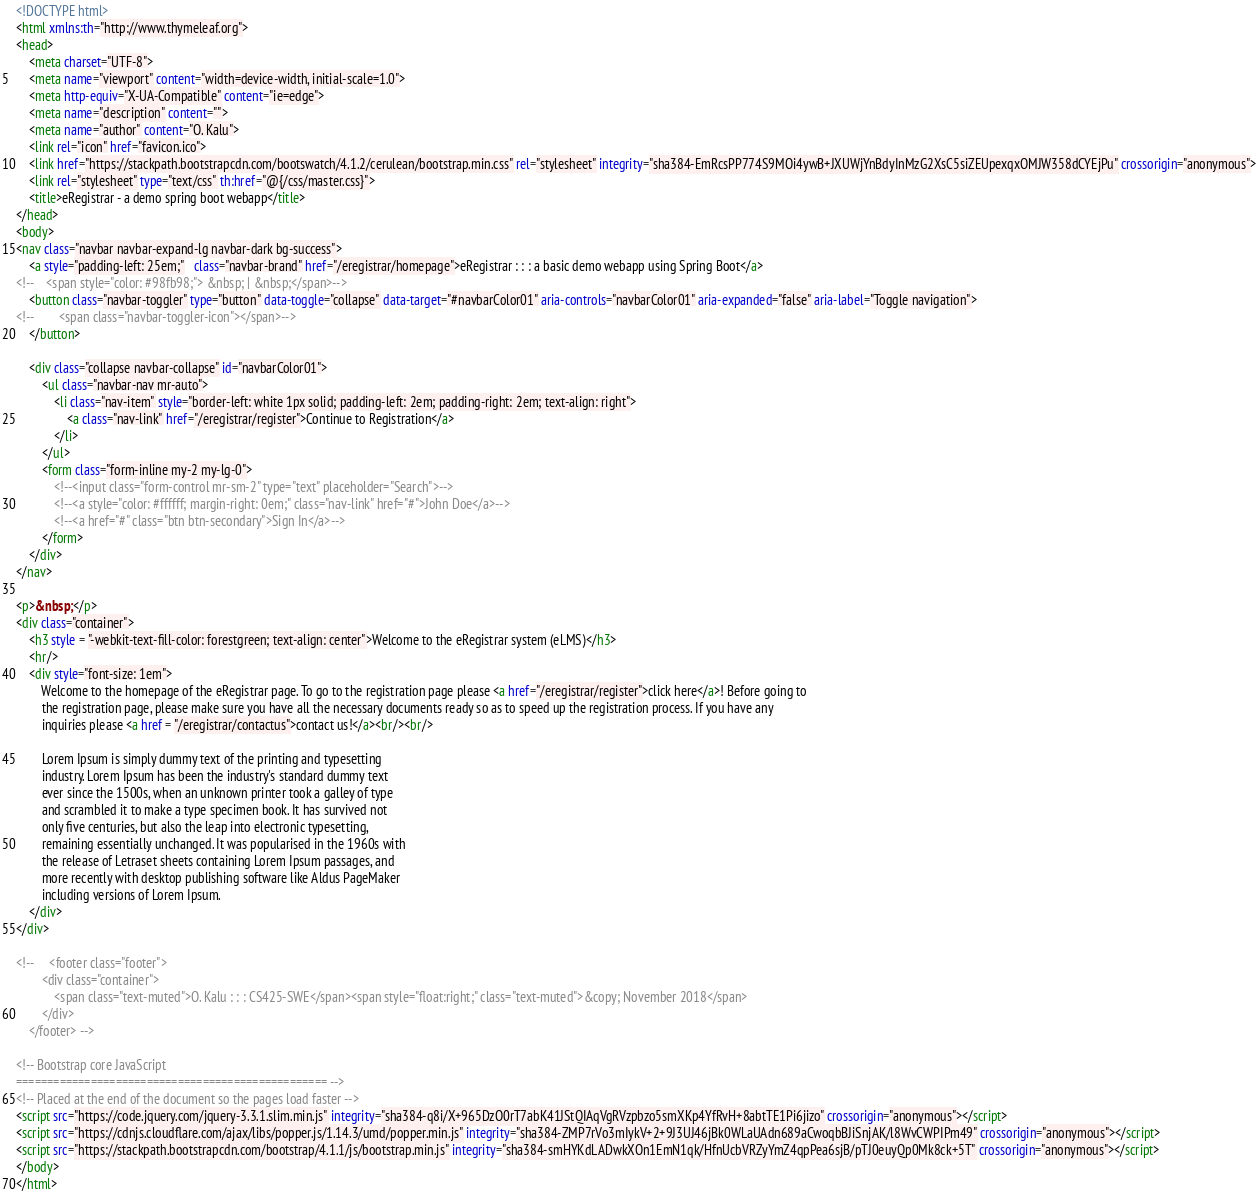Convert code to text. <code><loc_0><loc_0><loc_500><loc_500><_HTML_><!DOCTYPE html>
<html xmlns:th="http://www.thymeleaf.org">
<head>
    <meta charset="UTF-8">
    <meta name="viewport" content="width=device-width, initial-scale=1.0">
    <meta http-equiv="X-UA-Compatible" content="ie=edge">
    <meta name="description" content="">
    <meta name="author" content="O. Kalu">
    <link rel="icon" href="favicon.ico">
    <link href="https://stackpath.bootstrapcdn.com/bootswatch/4.1.2/cerulean/bootstrap.min.css" rel="stylesheet" integrity="sha384-EmRcsPP774S9MOi4ywB+JXUWjYnBdyInMzG2XsC5siZEUpexqxOMJW358dCYEjPu" crossorigin="anonymous">
    <link rel="stylesheet" type="text/css" th:href="@{/css/master.css}">
    <title>eRegistrar - a demo spring boot webapp</title>
</head>
<body>
<nav class="navbar navbar-expand-lg navbar-dark bg-success">
    <a style="padding-left: 25em;"   class="navbar-brand" href="/eregistrar/homepage">eRegistrar : : : a basic demo webapp using Spring Boot</a>
<!--    <span style="color: #98fb98;"> &nbsp; | &nbsp;</span>-->
    <button class="navbar-toggler" type="button" data-toggle="collapse" data-target="#navbarColor01" aria-controls="navbarColor01" aria-expanded="false" aria-label="Toggle navigation">
<!--        <span class="navbar-toggler-icon"></span>-->
    </button>

    <div class="collapse navbar-collapse" id="navbarColor01">
        <ul class="navbar-nav mr-auto">
            <li class="nav-item" style="border-left: white 1px solid; padding-left: 2em; padding-right: 2em; text-align: right">
                <a class="nav-link" href="/eregistrar/register">Continue to Registration</a>
            </li>
        </ul>
        <form class="form-inline my-2 my-lg-0">
            <!--<input class="form-control mr-sm-2" type="text" placeholder="Search">-->
            <!--<a style="color: #ffffff; margin-right: 0em;" class="nav-link" href="#">John Doe</a>-->
            <!--<a href="#" class="btn btn-secondary">Sign In</a>-->
        </form>
    </div>
</nav>

<p>&nbsp;</p>
<div class="container">
    <h3 style = "-webkit-text-fill-color: forestgreen; text-align: center">Welcome to the eRegistrar system (eLMS)</h3>
    <hr/>
    <div style="font-size: 1em">
        Welcome to the homepage of the eRegistrar page. To go to the registration page please <a href="/eregistrar/register">click here</a>! Before going to
        the registration page, please make sure you have all the necessary documents ready so as to speed up the registration process. If you have any
        inquiries please <a href = "/eregistrar/contactus">contact us!</a><br/><br/>

        Lorem Ipsum is simply dummy text of the printing and typesetting
        industry. Lorem Ipsum has been the industry's standard dummy text
        ever since the 1500s, when an unknown printer took a galley of type
        and scrambled it to make a type specimen book. It has survived not
        only five centuries, but also the leap into electronic typesetting,
        remaining essentially unchanged. It was popularised in the 1960s with
        the release of Letraset sheets containing Lorem Ipsum passages, and
        more recently with desktop publishing software like Aldus PageMaker
        including versions of Lorem Ipsum.
    </div>
</div>

<!--     <footer class="footer">
        <div class="container">
            <span class="text-muted">O. Kalu : : : CS425-SWE</span><span style="float:right;" class="text-muted">&copy; November 2018</span>
        </div>
    </footer> -->

<!-- Bootstrap core JavaScript
================================================== -->
<!-- Placed at the end of the document so the pages load faster -->
<script src="https://code.jquery.com/jquery-3.3.1.slim.min.js" integrity="sha384-q8i/X+965DzO0rT7abK41JStQIAqVgRVzpbzo5smXKp4YfRvH+8abtTE1Pi6jizo" crossorigin="anonymous"></script>
<script src="https://cdnjs.cloudflare.com/ajax/libs/popper.js/1.14.3/umd/popper.min.js" integrity="sha384-ZMP7rVo3mIykV+2+9J3UJ46jBk0WLaUAdn689aCwoqbBJiSnjAK/l8WvCWPIPm49" crossorigin="anonymous"></script>
<script src="https://stackpath.bootstrapcdn.com/bootstrap/4.1.1/js/bootstrap.min.js" integrity="sha384-smHYKdLADwkXOn1EmN1qk/HfnUcbVRZyYmZ4qpPea6sjB/pTJ0euyQp0Mk8ck+5T" crossorigin="anonymous"></script>
</body>
</html>
</code> 